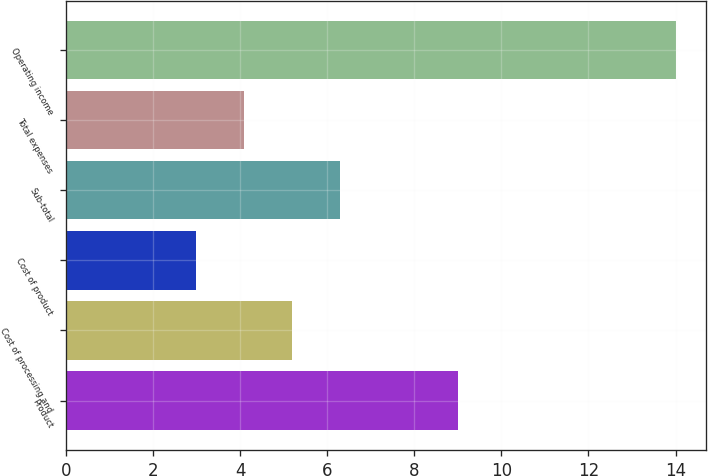Convert chart to OTSL. <chart><loc_0><loc_0><loc_500><loc_500><bar_chart><fcel>Product<fcel>Cost of processing and<fcel>Cost of product<fcel>Sub-total<fcel>Total expenses<fcel>Operating income<nl><fcel>9<fcel>5.2<fcel>3<fcel>6.3<fcel>4.1<fcel>14<nl></chart> 